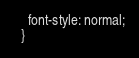<code> <loc_0><loc_0><loc_500><loc_500><_CSS_>    font-style: normal;
  }</code> 